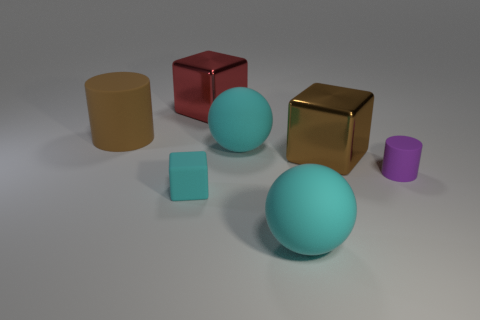Subtract all big brown blocks. How many blocks are left? 2 Subtract 1 cylinders. How many cylinders are left? 1 Subtract all red blocks. How many blocks are left? 2 Add 2 cyan cubes. How many objects exist? 9 Subtract all cylinders. How many objects are left? 5 Add 5 large red objects. How many large red objects are left? 6 Add 3 large shiny things. How many large shiny things exist? 5 Subtract 1 red blocks. How many objects are left? 6 Subtract all brown blocks. Subtract all brown cylinders. How many blocks are left? 2 Subtract all small cylinders. Subtract all tiny cyan rubber objects. How many objects are left? 5 